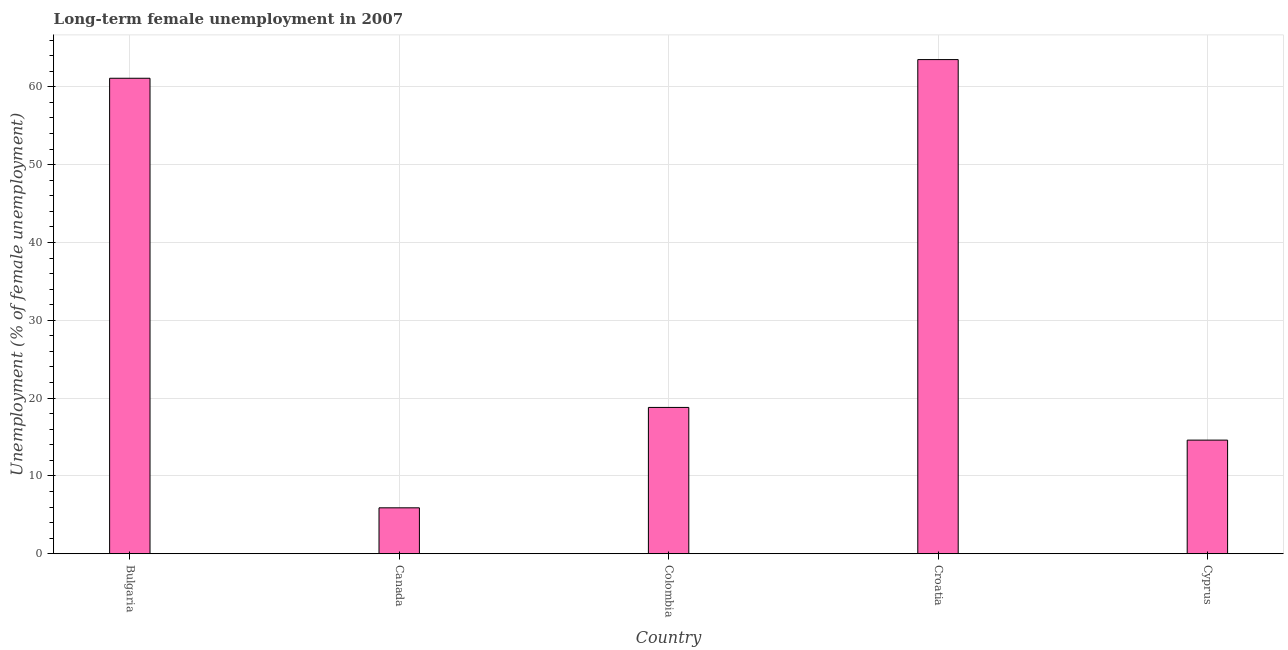Does the graph contain any zero values?
Keep it short and to the point. No. What is the title of the graph?
Provide a short and direct response. Long-term female unemployment in 2007. What is the label or title of the X-axis?
Give a very brief answer. Country. What is the label or title of the Y-axis?
Provide a short and direct response. Unemployment (% of female unemployment). What is the long-term female unemployment in Croatia?
Your answer should be very brief. 63.5. Across all countries, what is the maximum long-term female unemployment?
Keep it short and to the point. 63.5. Across all countries, what is the minimum long-term female unemployment?
Offer a terse response. 5.9. In which country was the long-term female unemployment maximum?
Make the answer very short. Croatia. In which country was the long-term female unemployment minimum?
Offer a terse response. Canada. What is the sum of the long-term female unemployment?
Ensure brevity in your answer.  163.9. What is the difference between the long-term female unemployment in Bulgaria and Colombia?
Make the answer very short. 42.3. What is the average long-term female unemployment per country?
Ensure brevity in your answer.  32.78. What is the median long-term female unemployment?
Give a very brief answer. 18.8. What is the ratio of the long-term female unemployment in Canada to that in Colombia?
Offer a terse response. 0.31. Is the difference between the long-term female unemployment in Colombia and Croatia greater than the difference between any two countries?
Offer a very short reply. No. What is the difference between the highest and the second highest long-term female unemployment?
Make the answer very short. 2.4. What is the difference between the highest and the lowest long-term female unemployment?
Your response must be concise. 57.6. How many bars are there?
Provide a succinct answer. 5. Are all the bars in the graph horizontal?
Keep it short and to the point. No. Are the values on the major ticks of Y-axis written in scientific E-notation?
Your answer should be very brief. No. What is the Unemployment (% of female unemployment) in Bulgaria?
Offer a terse response. 61.1. What is the Unemployment (% of female unemployment) in Canada?
Make the answer very short. 5.9. What is the Unemployment (% of female unemployment) in Colombia?
Provide a succinct answer. 18.8. What is the Unemployment (% of female unemployment) of Croatia?
Keep it short and to the point. 63.5. What is the Unemployment (% of female unemployment) of Cyprus?
Provide a short and direct response. 14.6. What is the difference between the Unemployment (% of female unemployment) in Bulgaria and Canada?
Keep it short and to the point. 55.2. What is the difference between the Unemployment (% of female unemployment) in Bulgaria and Colombia?
Your answer should be very brief. 42.3. What is the difference between the Unemployment (% of female unemployment) in Bulgaria and Cyprus?
Give a very brief answer. 46.5. What is the difference between the Unemployment (% of female unemployment) in Canada and Croatia?
Keep it short and to the point. -57.6. What is the difference between the Unemployment (% of female unemployment) in Canada and Cyprus?
Ensure brevity in your answer.  -8.7. What is the difference between the Unemployment (% of female unemployment) in Colombia and Croatia?
Keep it short and to the point. -44.7. What is the difference between the Unemployment (% of female unemployment) in Croatia and Cyprus?
Give a very brief answer. 48.9. What is the ratio of the Unemployment (% of female unemployment) in Bulgaria to that in Canada?
Offer a very short reply. 10.36. What is the ratio of the Unemployment (% of female unemployment) in Bulgaria to that in Colombia?
Provide a succinct answer. 3.25. What is the ratio of the Unemployment (% of female unemployment) in Bulgaria to that in Cyprus?
Provide a succinct answer. 4.18. What is the ratio of the Unemployment (% of female unemployment) in Canada to that in Colombia?
Your response must be concise. 0.31. What is the ratio of the Unemployment (% of female unemployment) in Canada to that in Croatia?
Your answer should be very brief. 0.09. What is the ratio of the Unemployment (% of female unemployment) in Canada to that in Cyprus?
Give a very brief answer. 0.4. What is the ratio of the Unemployment (% of female unemployment) in Colombia to that in Croatia?
Keep it short and to the point. 0.3. What is the ratio of the Unemployment (% of female unemployment) in Colombia to that in Cyprus?
Your answer should be compact. 1.29. What is the ratio of the Unemployment (% of female unemployment) in Croatia to that in Cyprus?
Ensure brevity in your answer.  4.35. 